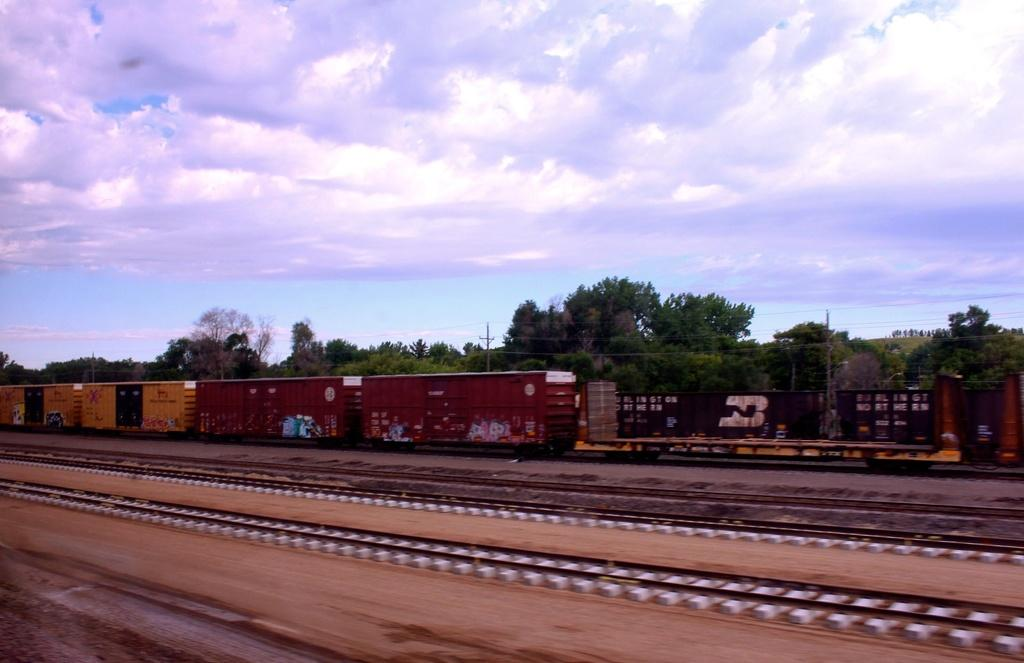What is located on the left side of the image? There is a train on the left side of the image. What can be seen in the background of the image? There are trees in the background of the image. What is visible at the top of the image? The sky is visible at the top of the image. How many lips can be seen in the image? There are no lips present in the image. What type of territory is depicted in the image? The image does not depict any specific territory; it features a train, trees, and the sky. 